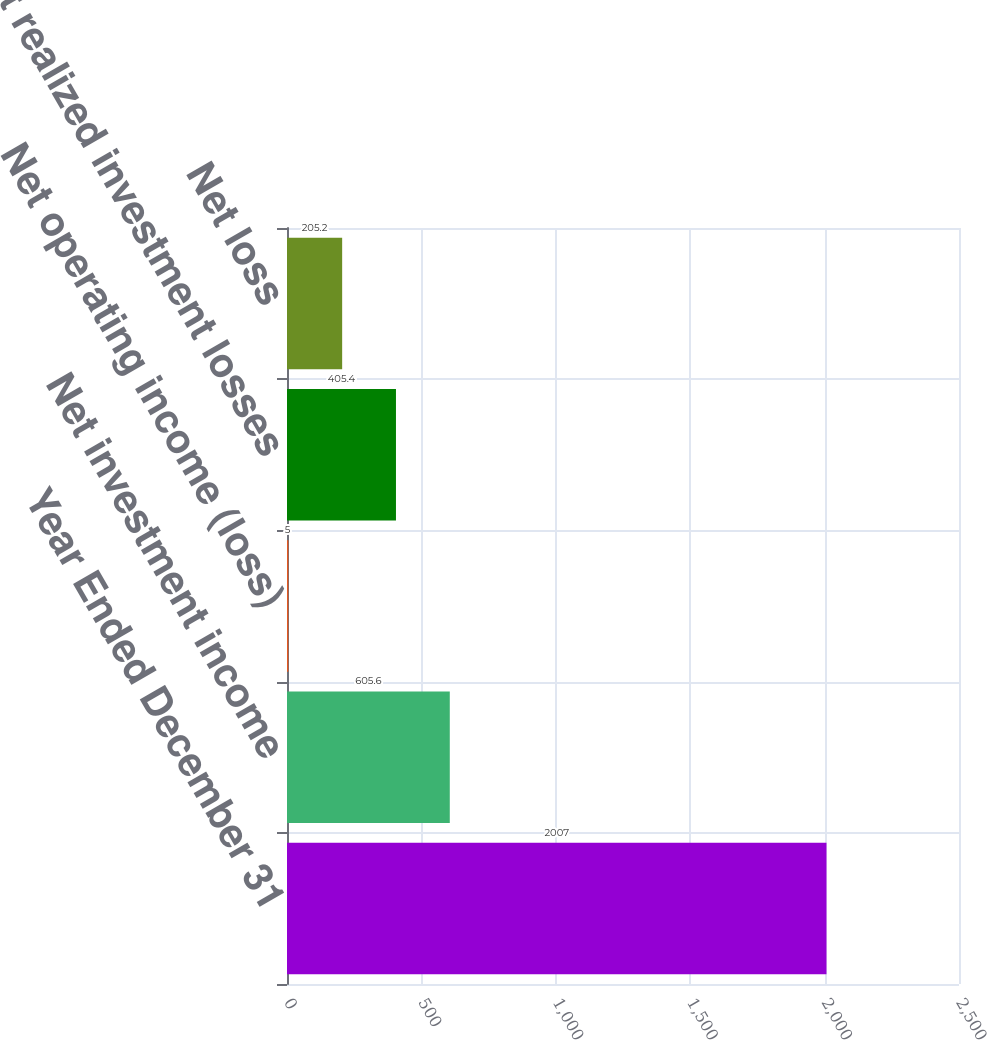Convert chart. <chart><loc_0><loc_0><loc_500><loc_500><bar_chart><fcel>Year Ended December 31<fcel>Net investment income<fcel>Net operating income (loss)<fcel>Net realized investment losses<fcel>Net loss<nl><fcel>2007<fcel>605.6<fcel>5<fcel>405.4<fcel>205.2<nl></chart> 